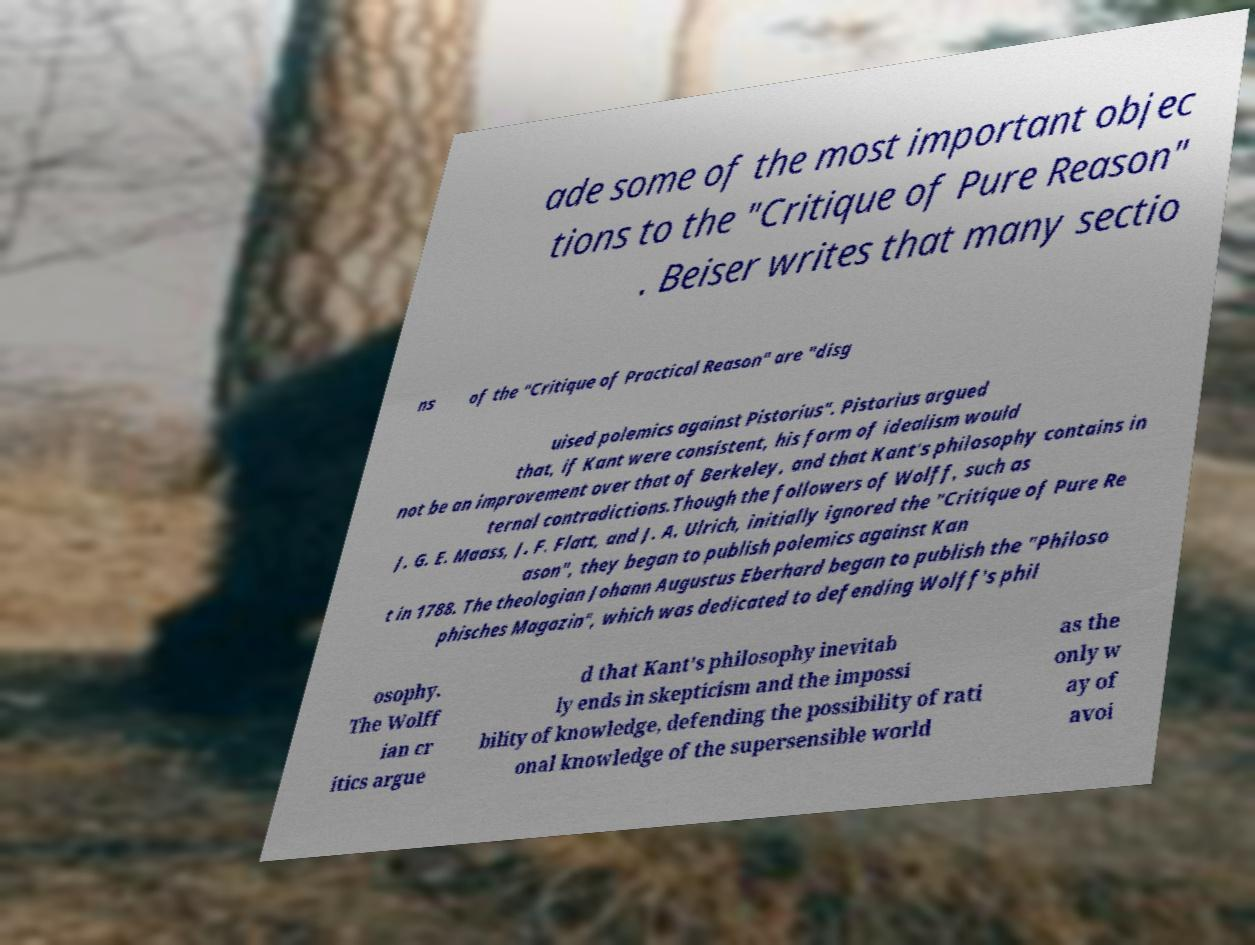Can you accurately transcribe the text from the provided image for me? ade some of the most important objec tions to the "Critique of Pure Reason" . Beiser writes that many sectio ns of the "Critique of Practical Reason" are "disg uised polemics against Pistorius". Pistorius argued that, if Kant were consistent, his form of idealism would not be an improvement over that of Berkeley, and that Kant's philosophy contains in ternal contradictions.Though the followers of Wolff, such as J. G. E. Maass, J. F. Flatt, and J. A. Ulrich, initially ignored the "Critique of Pure Re ason", they began to publish polemics against Kan t in 1788. The theologian Johann Augustus Eberhard began to publish the "Philoso phisches Magazin", which was dedicated to defending Wolff's phil osophy. The Wolff ian cr itics argue d that Kant's philosophy inevitab ly ends in skepticism and the impossi bility of knowledge, defending the possibility of rati onal knowledge of the supersensible world as the only w ay of avoi 